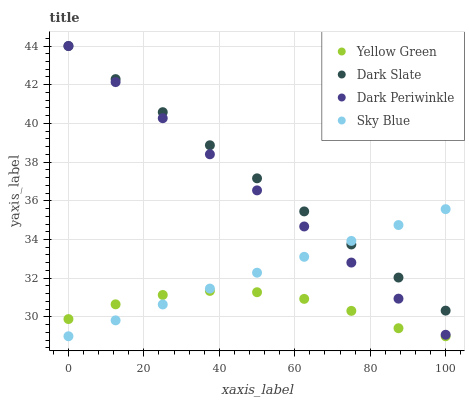Does Yellow Green have the minimum area under the curve?
Answer yes or no. Yes. Does Dark Slate have the maximum area under the curve?
Answer yes or no. Yes. Does Sky Blue have the minimum area under the curve?
Answer yes or no. No. Does Sky Blue have the maximum area under the curve?
Answer yes or no. No. Is Dark Periwinkle the smoothest?
Answer yes or no. Yes. Is Yellow Green the roughest?
Answer yes or no. Yes. Is Sky Blue the smoothest?
Answer yes or no. No. Is Sky Blue the roughest?
Answer yes or no. No. Does Sky Blue have the lowest value?
Answer yes or no. Yes. Does Dark Periwinkle have the lowest value?
Answer yes or no. No. Does Dark Periwinkle have the highest value?
Answer yes or no. Yes. Does Sky Blue have the highest value?
Answer yes or no. No. Is Yellow Green less than Dark Slate?
Answer yes or no. Yes. Is Dark Slate greater than Yellow Green?
Answer yes or no. Yes. Does Dark Slate intersect Dark Periwinkle?
Answer yes or no. Yes. Is Dark Slate less than Dark Periwinkle?
Answer yes or no. No. Is Dark Slate greater than Dark Periwinkle?
Answer yes or no. No. Does Yellow Green intersect Dark Slate?
Answer yes or no. No. 